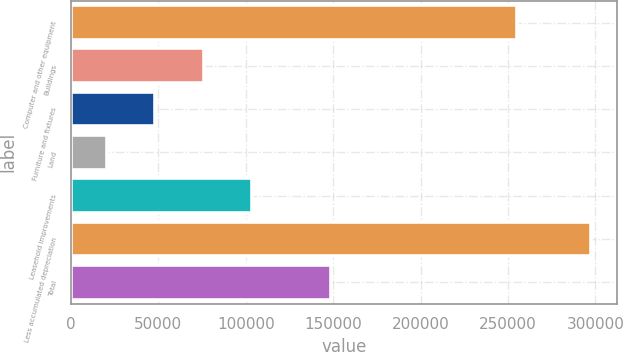Convert chart. <chart><loc_0><loc_0><loc_500><loc_500><bar_chart><fcel>Computer and other equipment<fcel>Buildings<fcel>Furniture and fixtures<fcel>Land<fcel>Leasehold improvements<fcel>Less accumulated depreciation<fcel>Total<nl><fcel>255054<fcel>75807<fcel>48110.5<fcel>20414<fcel>103504<fcel>297379<fcel>148580<nl></chart> 